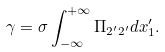<formula> <loc_0><loc_0><loc_500><loc_500>\gamma = \sigma \int ^ { + \infty } _ { - \infty } \Pi _ { 2 ^ { \prime } 2 ^ { \prime } } d x ^ { \prime } _ { 1 } .</formula> 